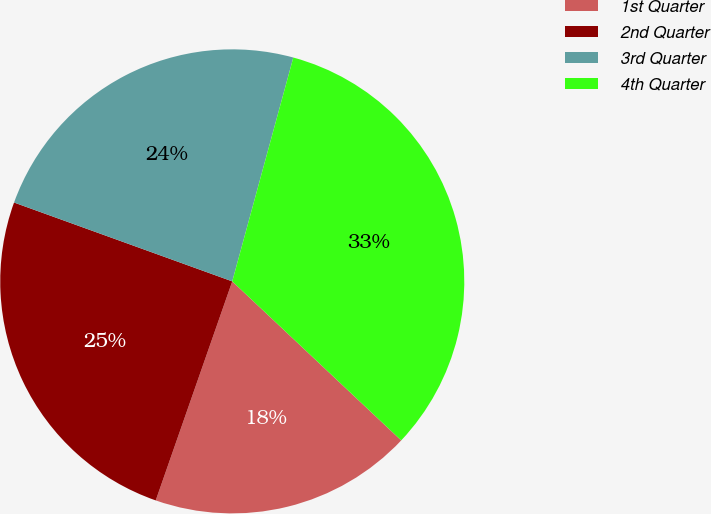Convert chart to OTSL. <chart><loc_0><loc_0><loc_500><loc_500><pie_chart><fcel>1st Quarter<fcel>2nd Quarter<fcel>3rd Quarter<fcel>4th Quarter<nl><fcel>18.33%<fcel>25.17%<fcel>23.72%<fcel>32.78%<nl></chart> 